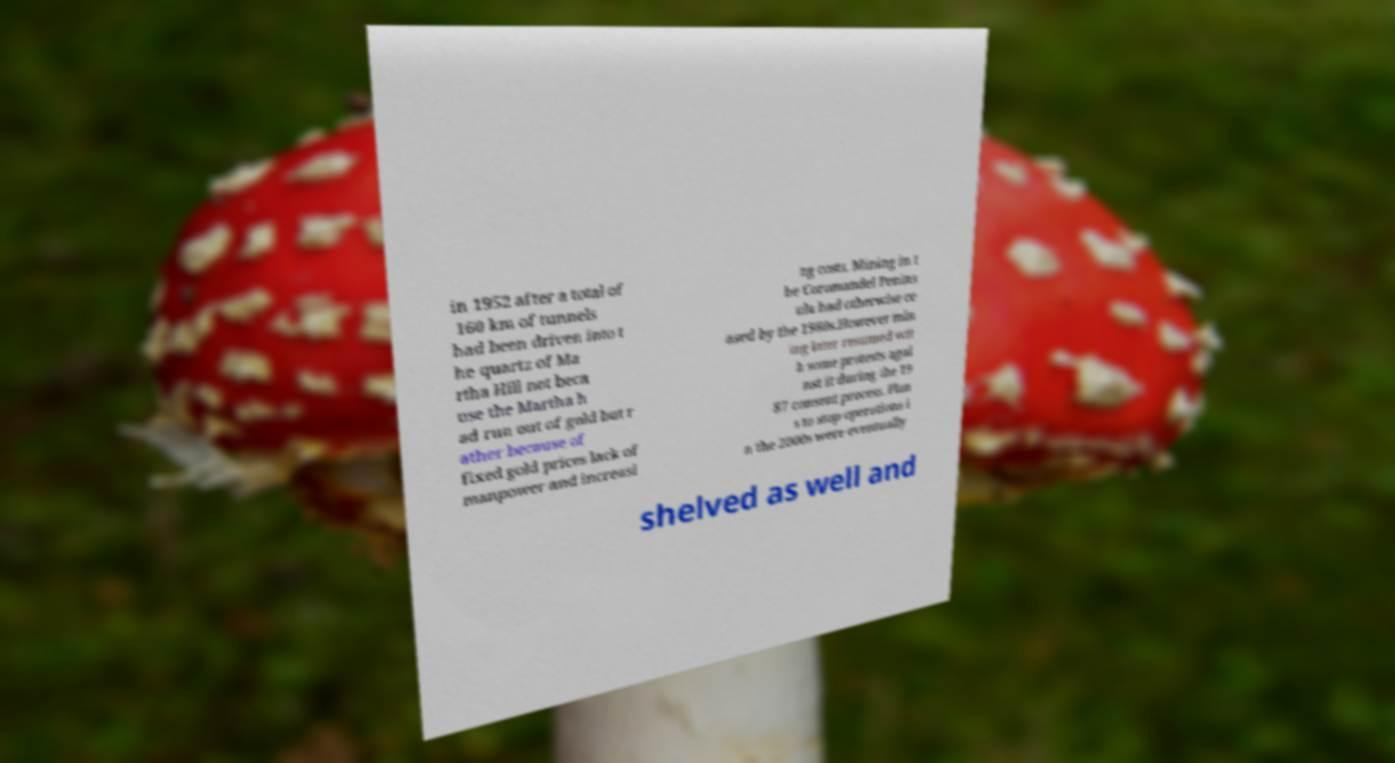There's text embedded in this image that I need extracted. Can you transcribe it verbatim? in 1952 after a total of 160 km of tunnels had been driven into t he quartz of Ma rtha Hill not beca use the Martha h ad run out of gold but r ather because of fixed gold prices lack of manpower and increasi ng costs. Mining in t he Coromandel Penins ula had otherwise ce ased by the 1980s.However min ing later resumed wit h some protests agai nst it during the 19 87 consent process. Plan s to stop operations i n the 2000s were eventually shelved as well and 